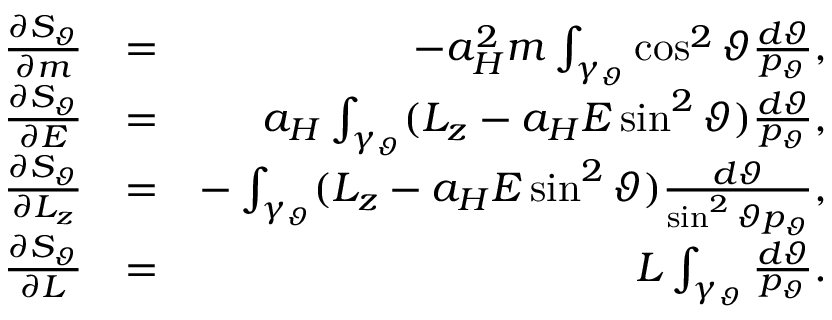Convert formula to latex. <formula><loc_0><loc_0><loc_500><loc_500>\begin{array} { r l r } { \frac { \partial S _ { \vartheta } } { \partial m } } & { = } & { - a _ { H } ^ { 2 } m \int _ { \gamma _ { \vartheta } } \cos ^ { 2 } \vartheta \frac { d \vartheta } { p _ { \vartheta } } , } \\ { \frac { \partial S _ { \vartheta } } { \partial E } } & { = } & { a _ { H } \int _ { \gamma _ { \vartheta } } ( L _ { z } - a _ { H } E \sin ^ { 2 } \vartheta ) \frac { d \vartheta } { p _ { \vartheta } } , } \\ { \frac { \partial S _ { \vartheta } } { \partial L _ { z } } } & { = } & { - \int _ { \gamma _ { \vartheta } } ( L _ { z } - a _ { H } E \sin ^ { 2 } \vartheta ) \frac { d \vartheta } { \sin ^ { 2 } \vartheta p _ { \vartheta } } , } \\ { \frac { \partial S _ { \vartheta } } { \partial L } } & { = } & { L \int _ { \gamma _ { \vartheta } } \frac { d \vartheta } { p _ { \vartheta } } . } \end{array}</formula> 